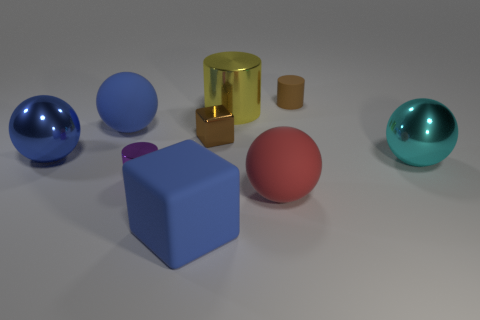Add 1 large cyan objects. How many objects exist? 10 Subtract all tiny cylinders. How many cylinders are left? 1 Subtract all cylinders. How many objects are left? 6 Subtract all big cyan spheres. Subtract all large red rubber objects. How many objects are left? 7 Add 8 tiny matte cylinders. How many tiny matte cylinders are left? 9 Add 3 gray matte things. How many gray matte things exist? 3 Subtract all blue blocks. How many blocks are left? 1 Subtract 0 red cubes. How many objects are left? 9 Subtract 3 cylinders. How many cylinders are left? 0 Subtract all cyan cubes. Subtract all green spheres. How many cubes are left? 2 